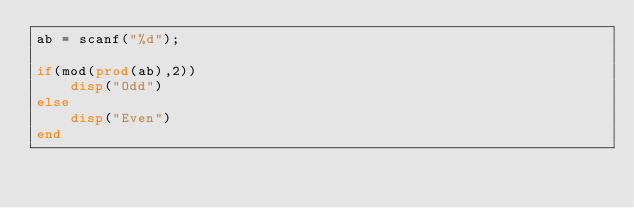Convert code to text. <code><loc_0><loc_0><loc_500><loc_500><_Octave_>ab = scanf("%d");
 
if(mod(prod(ab),2))
    disp("Odd")
else
    disp("Even")
end</code> 